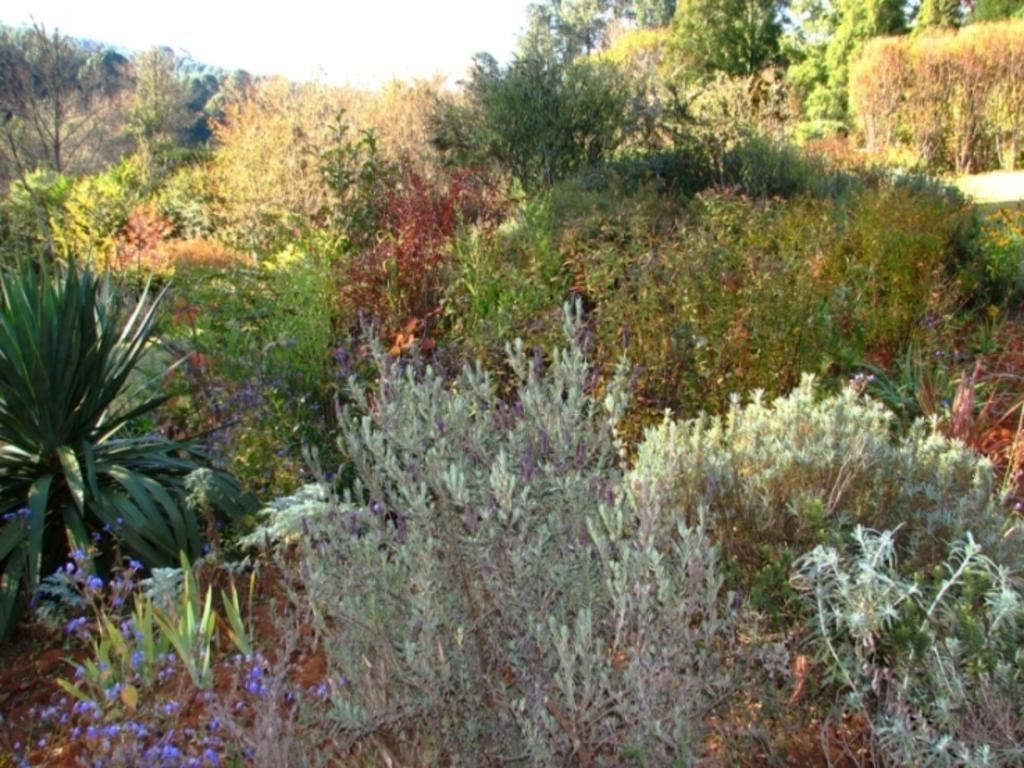What can be seen at the top of the image? The sky is visible towards the top of the image. What type of vegetation is present in the image? There are plants and trees in the image. Where are the flowers located in the image? The flowers are towards the bottom of the image. What type of pollution can be seen in the image? There is no pollution visible in the image. What flavor of ice cream is being served in the yard? There is no ice cream or yard present in the image. 